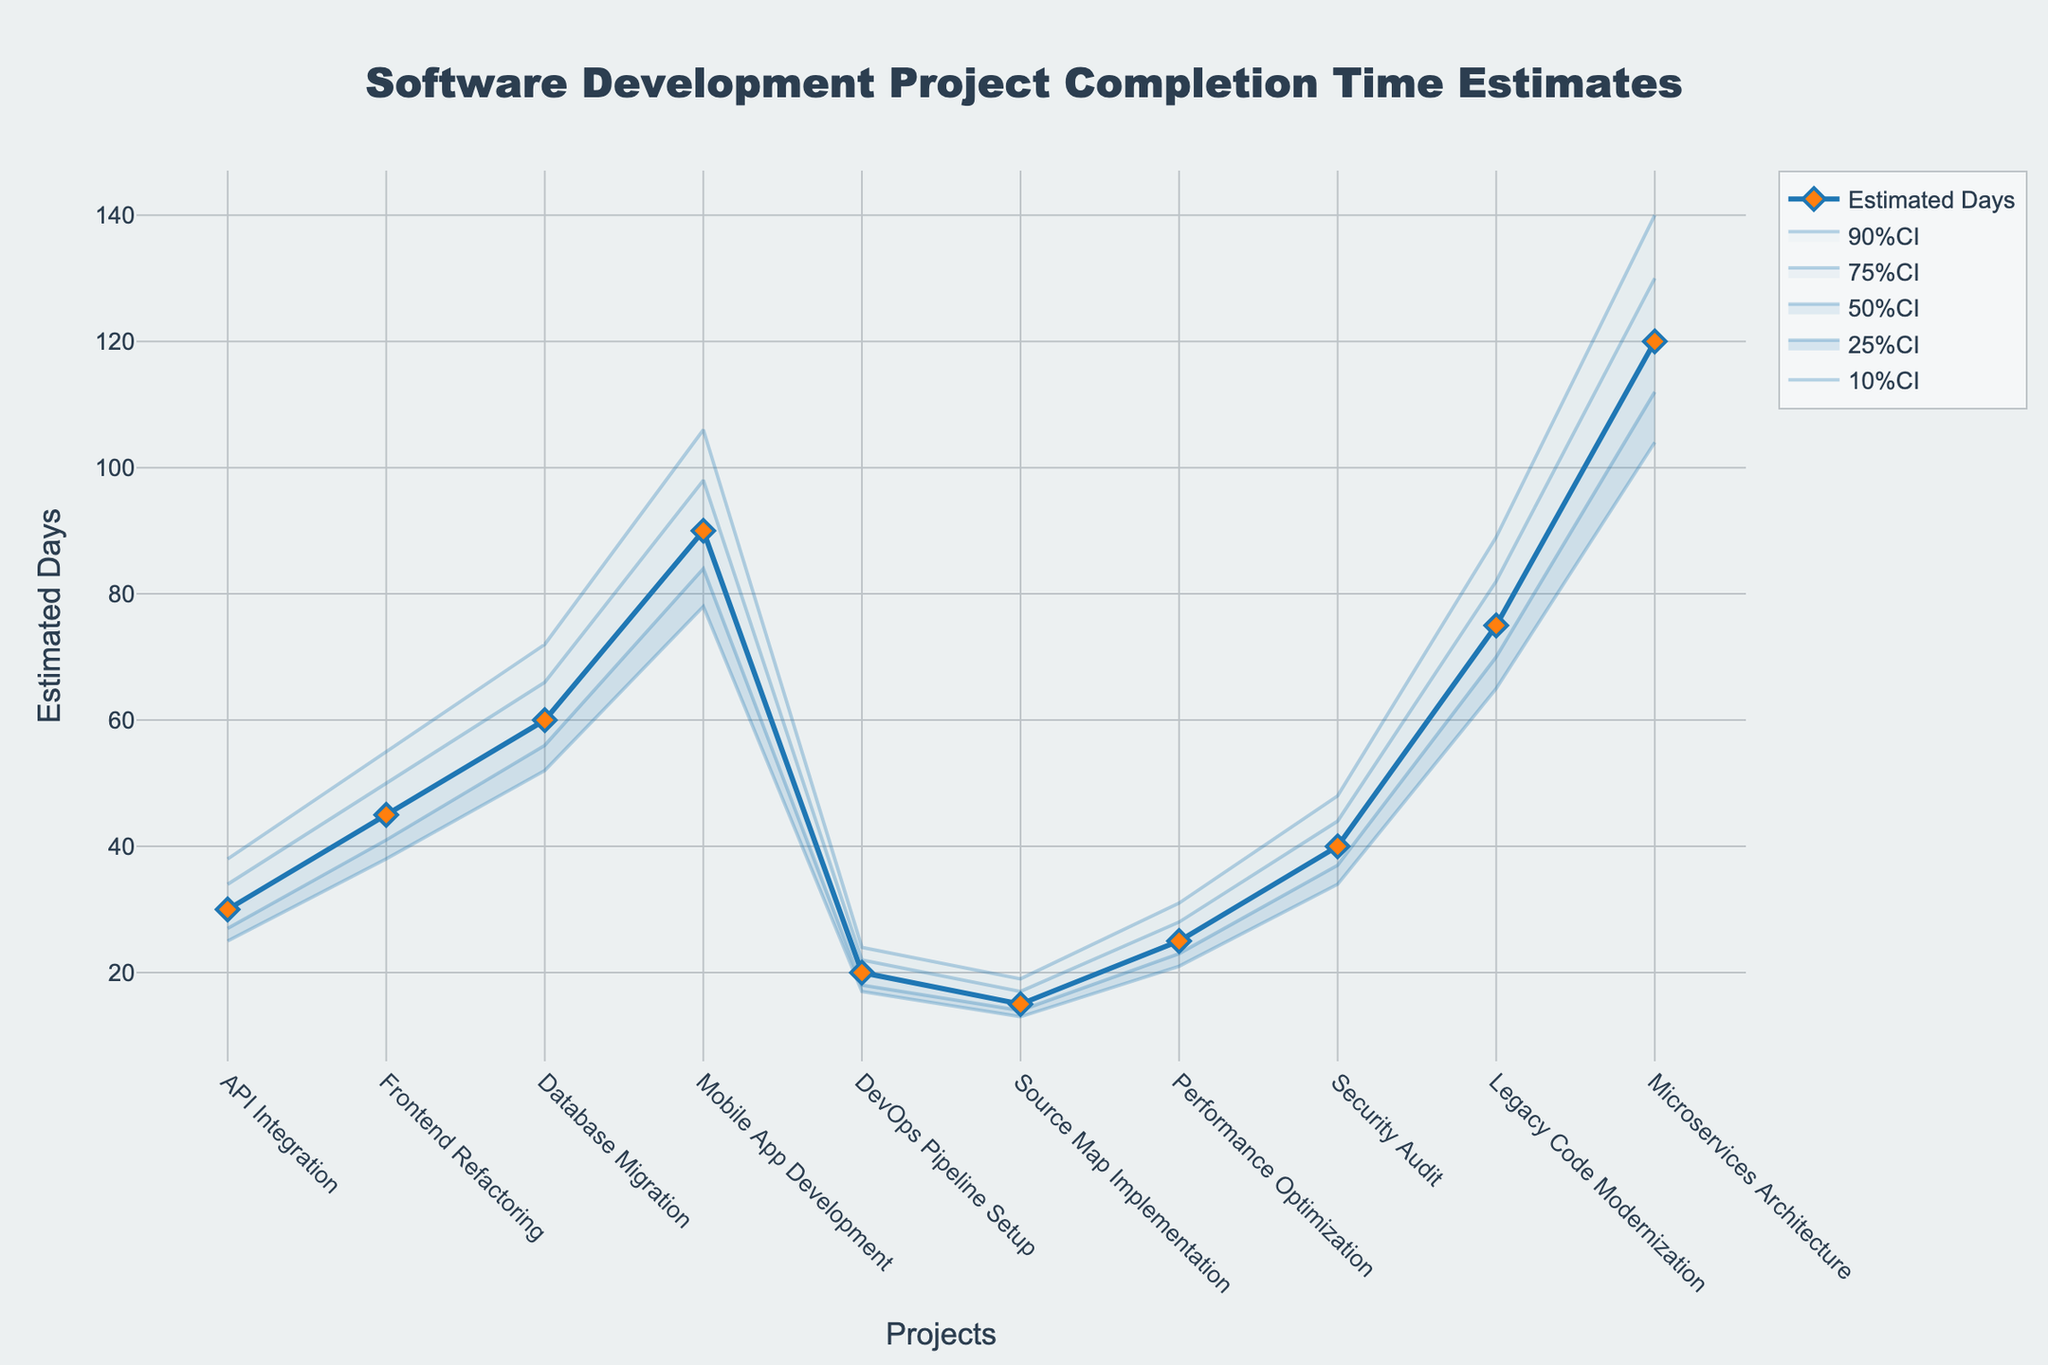what is the title of the figure? The title is typically located at the top of the figure. For this figure, it reads 'Software Development Project Completion Time Estimates'.
Answer: Software Development Project Completion Time Estimates What does the x-axis represent? The x-axis of the figure typically shows the categories being analyzed. In this case, it represents the 'Projects'.
Answer: Projects What is the estimated completion time for 'Frontend Refactoring'? The estimated completion time can be found by looking at the data point for 'Frontend Refactoring' on the y-axis. It is 45 days.
Answer: 45 days Which project has the widest confidence interval range? To find the project with the widest confidence interval, compare the difference between the 10%CI and 90%CI for each project. 'Mobile App Development' has the widest range (106 - 78 = 28 days).
Answer: Mobile App Development How many projects have an estimated completion time greater than 50 days? Count the number of projects in the estimated days line that are greater than 50 on the y-axis. There are 4 such projects: Database Migration, Mobile App Development, Legacy Code Modernization, and Microservices Architecture.
Answer: 4 What is the median estimate for the 'Database Migration' project? The median can be found in the 50% CI column for 'Database Migration'. It is 60 days.
Answer: 60 days Which project is estimated to take the least amount of time? Find the project with the lowest estimated days on the y-axis. 'Source Map Implementation' is estimated at 15 days.
Answer: Source Map Implementation How does the completion time for 'Performance Optimization' compare to 'DevOps Pipeline Setup'? Compare their estimated completion times. 'Performance Optimization' is estimated to take 25 days, while 'DevOps Pipeline Setup' is estimated to take 20 days. Performance Optimization takes 5 days longer.
Answer: Performance Optimization takes 5 days longer Are there any overlapping confidence intervals between 'Frontend Refactoring' and 'Database Migration'? Compare the confidence intervals: 'Frontend Refactoring' has a range of [38, 55], and 'Database Migration' has a range of [52, 72]. They overlap between 52 and 55 days.
Answer: Yes, between 52 and 55 days What is the difference between the 90%CI and the 10%CI for 'Microservices Architecture'? Subtract the 10%CI value from the 90%CI value for 'Microservices Architecture'. 140 - 104 = 36 days.
Answer: 36 days 